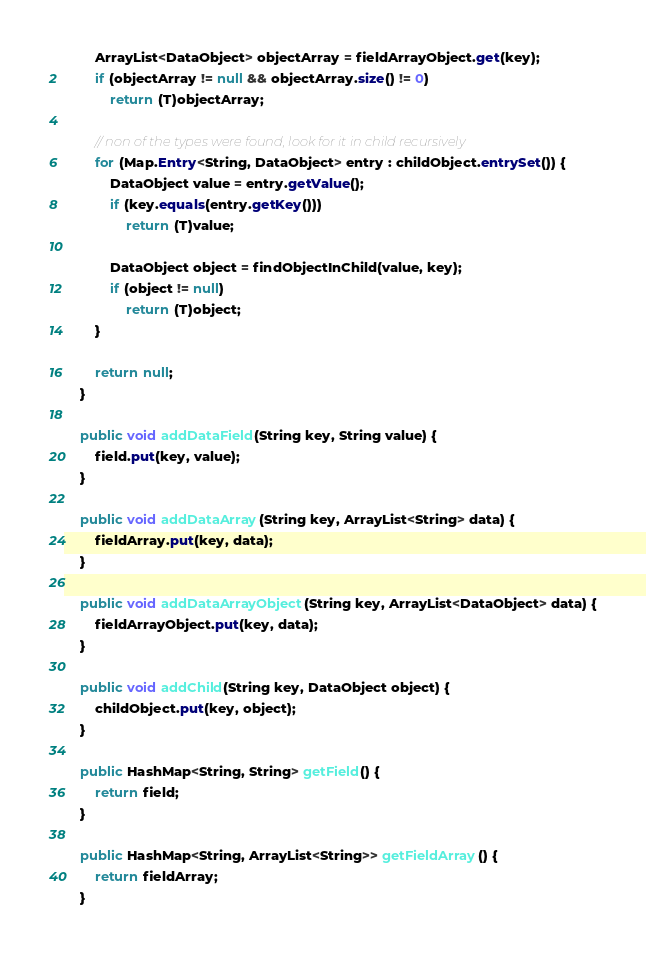<code> <loc_0><loc_0><loc_500><loc_500><_Java_>		ArrayList<DataObject> objectArray = fieldArrayObject.get(key);
		if (objectArray != null && objectArray.size() != 0)
			return (T)objectArray;
		
		// non of the types were found, look for it in child recursively
		for (Map.Entry<String, DataObject> entry : childObject.entrySet()) {
			DataObject value = entry.getValue();
			if (key.equals(entry.getKey()))
				return (T)value;
			
			DataObject object = findObjectInChild(value, key);
			if (object != null)
				return (T)object;
		}

		return null;
	}

	public void addDataField(String key, String value) {
		field.put(key, value);
	}

	public void addDataArray(String key, ArrayList<String> data) {
		fieldArray.put(key, data);
	}

	public void addDataArrayObject(String key, ArrayList<DataObject> data) {
		fieldArrayObject.put(key, data);
	}

	public void addChild(String key, DataObject object) {
		childObject.put(key, object);
	}

	public HashMap<String, String> getField() {
		return field;
	}

	public HashMap<String, ArrayList<String>> getFieldArray() {
		return fieldArray;
	}
</code> 